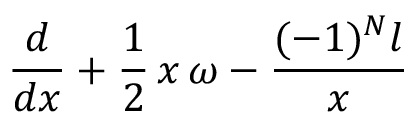Convert formula to latex. <formula><loc_0><loc_0><loc_500><loc_500>\frac { d } { d x } + \frac { 1 } { 2 } \, x \, \omega - \frac { ( - 1 ) ^ { N } l } { x }</formula> 